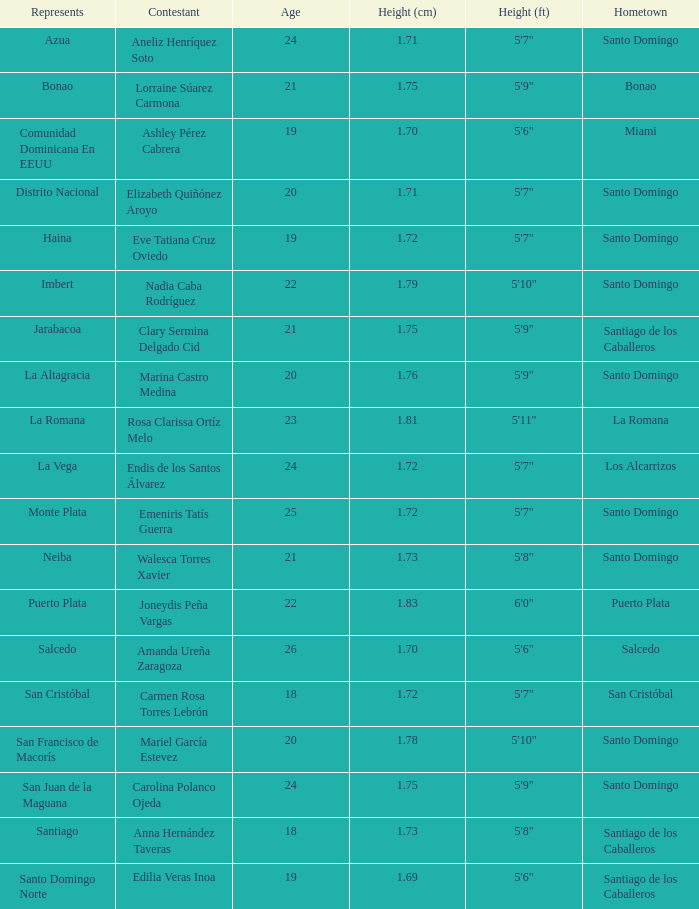Indicate the representation for La Altagracia. 